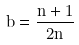Convert formula to latex. <formula><loc_0><loc_0><loc_500><loc_500>b = \frac { n + 1 } { 2 n }</formula> 